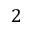Convert formula to latex. <formula><loc_0><loc_0><loc_500><loc_500>2</formula> 